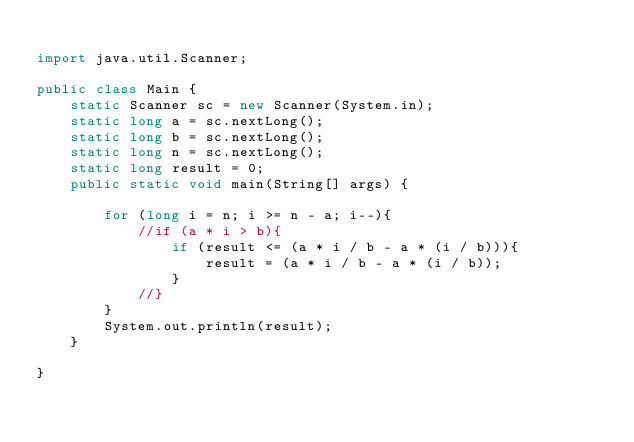Convert code to text. <code><loc_0><loc_0><loc_500><loc_500><_Java_>
import java.util.Scanner;

public class Main {
    static Scanner sc = new Scanner(System.in);
    static long a = sc.nextLong();
    static long b = sc.nextLong();
    static long n = sc.nextLong();
    static long result = 0;
    public static void main(String[] args) {

        for (long i = n; i >= n - a; i--){
            //if (a * i > b){
                if (result <= (a * i / b - a * (i / b))){
                    result = (a * i / b - a * (i / b));
                }
            //}
        }
        System.out.println(result);
    }

}
</code> 